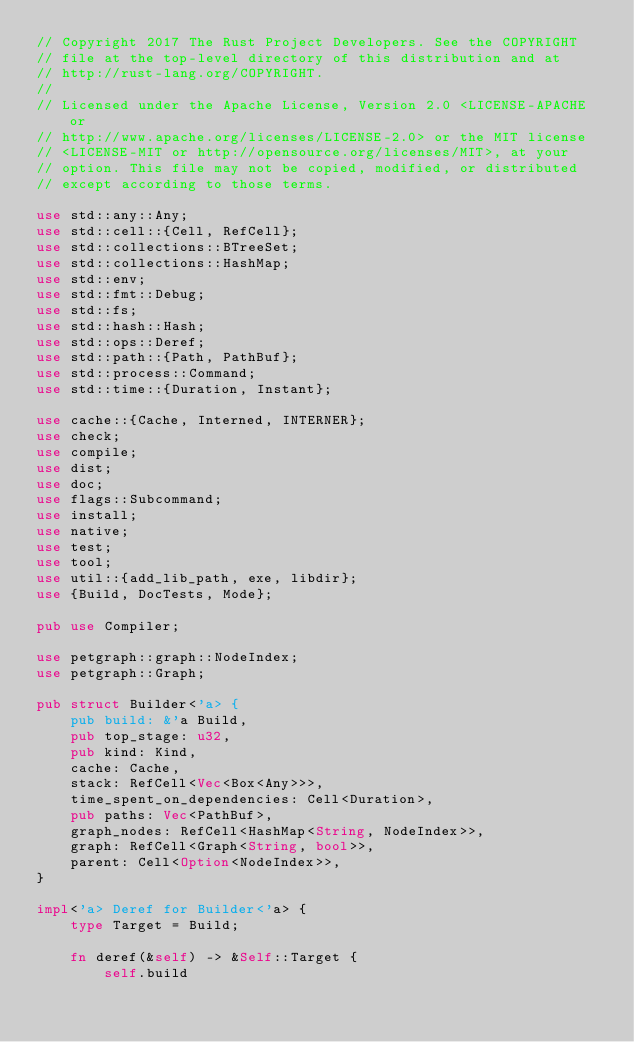Convert code to text. <code><loc_0><loc_0><loc_500><loc_500><_Rust_>// Copyright 2017 The Rust Project Developers. See the COPYRIGHT
// file at the top-level directory of this distribution and at
// http://rust-lang.org/COPYRIGHT.
//
// Licensed under the Apache License, Version 2.0 <LICENSE-APACHE or
// http://www.apache.org/licenses/LICENSE-2.0> or the MIT license
// <LICENSE-MIT or http://opensource.org/licenses/MIT>, at your
// option. This file may not be copied, modified, or distributed
// except according to those terms.

use std::any::Any;
use std::cell::{Cell, RefCell};
use std::collections::BTreeSet;
use std::collections::HashMap;
use std::env;
use std::fmt::Debug;
use std::fs;
use std::hash::Hash;
use std::ops::Deref;
use std::path::{Path, PathBuf};
use std::process::Command;
use std::time::{Duration, Instant};

use cache::{Cache, Interned, INTERNER};
use check;
use compile;
use dist;
use doc;
use flags::Subcommand;
use install;
use native;
use test;
use tool;
use util::{add_lib_path, exe, libdir};
use {Build, DocTests, Mode};

pub use Compiler;

use petgraph::graph::NodeIndex;
use petgraph::Graph;

pub struct Builder<'a> {
    pub build: &'a Build,
    pub top_stage: u32,
    pub kind: Kind,
    cache: Cache,
    stack: RefCell<Vec<Box<Any>>>,
    time_spent_on_dependencies: Cell<Duration>,
    pub paths: Vec<PathBuf>,
    graph_nodes: RefCell<HashMap<String, NodeIndex>>,
    graph: RefCell<Graph<String, bool>>,
    parent: Cell<Option<NodeIndex>>,
}

impl<'a> Deref for Builder<'a> {
    type Target = Build;

    fn deref(&self) -> &Self::Target {
        self.build</code> 